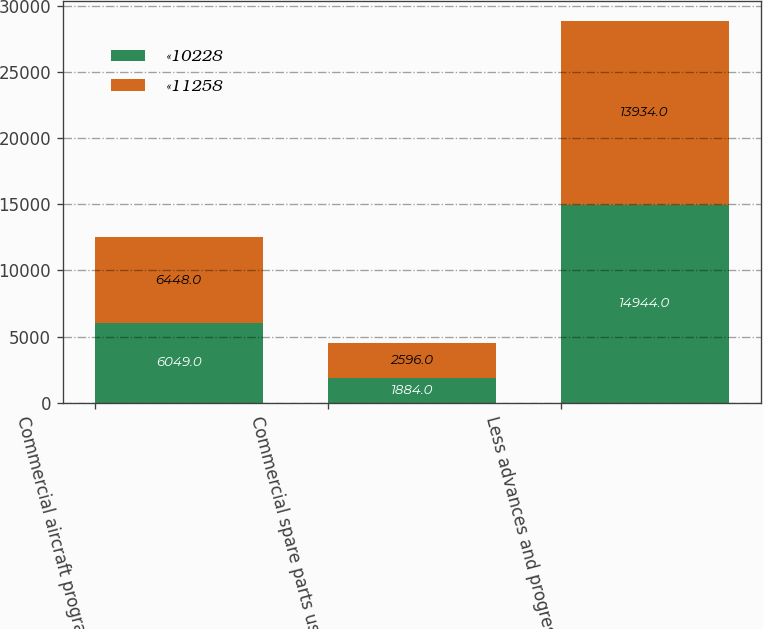Convert chart. <chart><loc_0><loc_0><loc_500><loc_500><stacked_bar_chart><ecel><fcel>Commercial aircraft programs<fcel>Commercial spare parts used<fcel>Less advances and progress<nl><fcel>«10228<fcel>6049<fcel>1884<fcel>14944<nl><fcel>«11258<fcel>6448<fcel>2596<fcel>13934<nl></chart> 